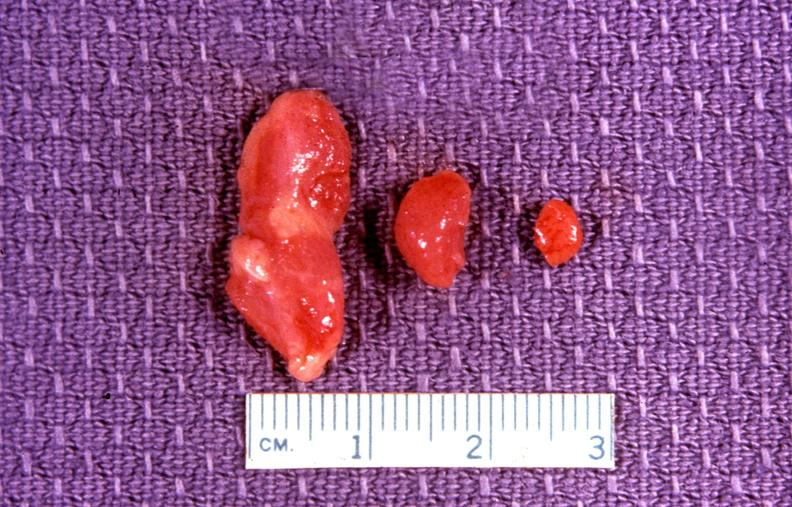where does this belong to?
Answer the question using a single word or phrase. Endocrine system 